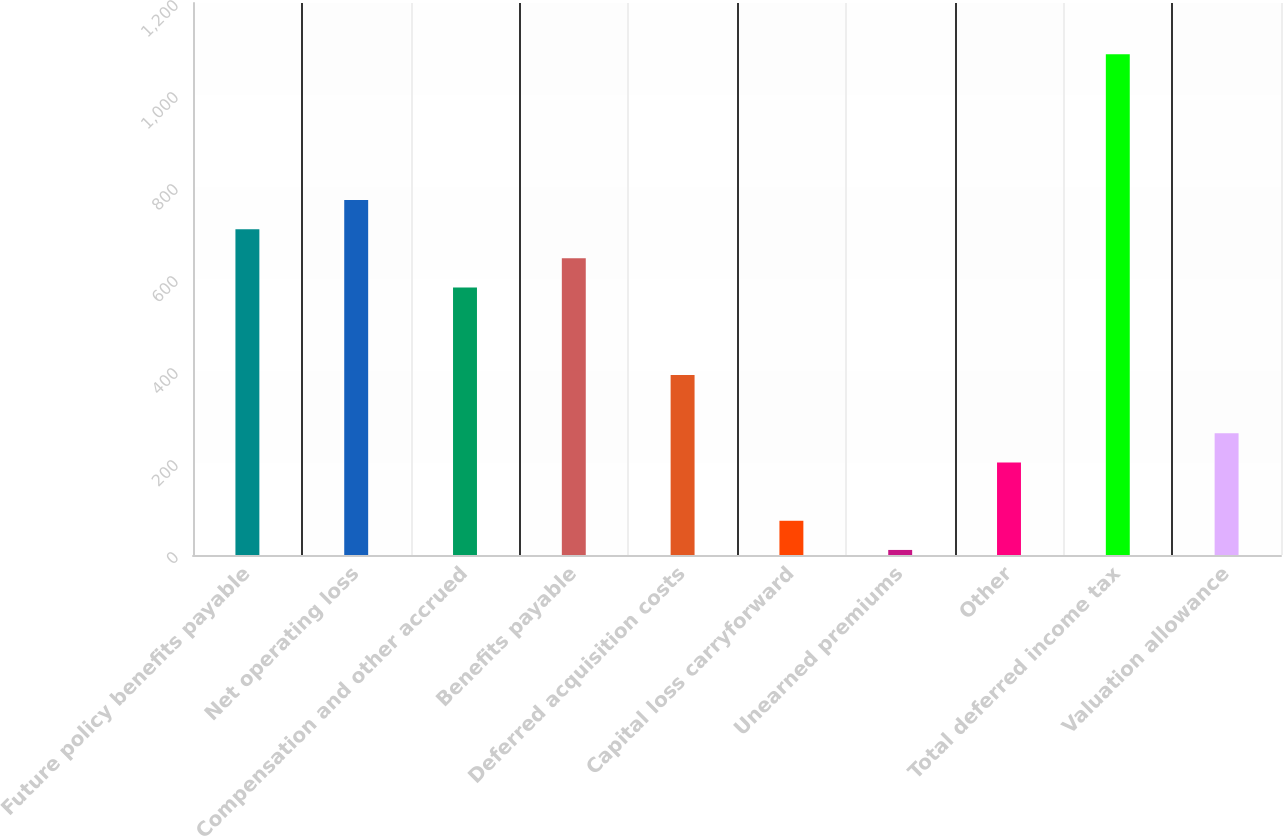<chart> <loc_0><loc_0><loc_500><loc_500><bar_chart><fcel>Future policy benefits payable<fcel>Net operating loss<fcel>Compensation and other accrued<fcel>Benefits payable<fcel>Deferred acquisition costs<fcel>Capital loss carryforward<fcel>Unearned premiums<fcel>Other<fcel>Total deferred income tax<fcel>Valuation allowance<nl><fcel>708.4<fcel>771.8<fcel>581.6<fcel>645<fcel>391.4<fcel>74.4<fcel>11<fcel>201.2<fcel>1088.8<fcel>264.6<nl></chart> 